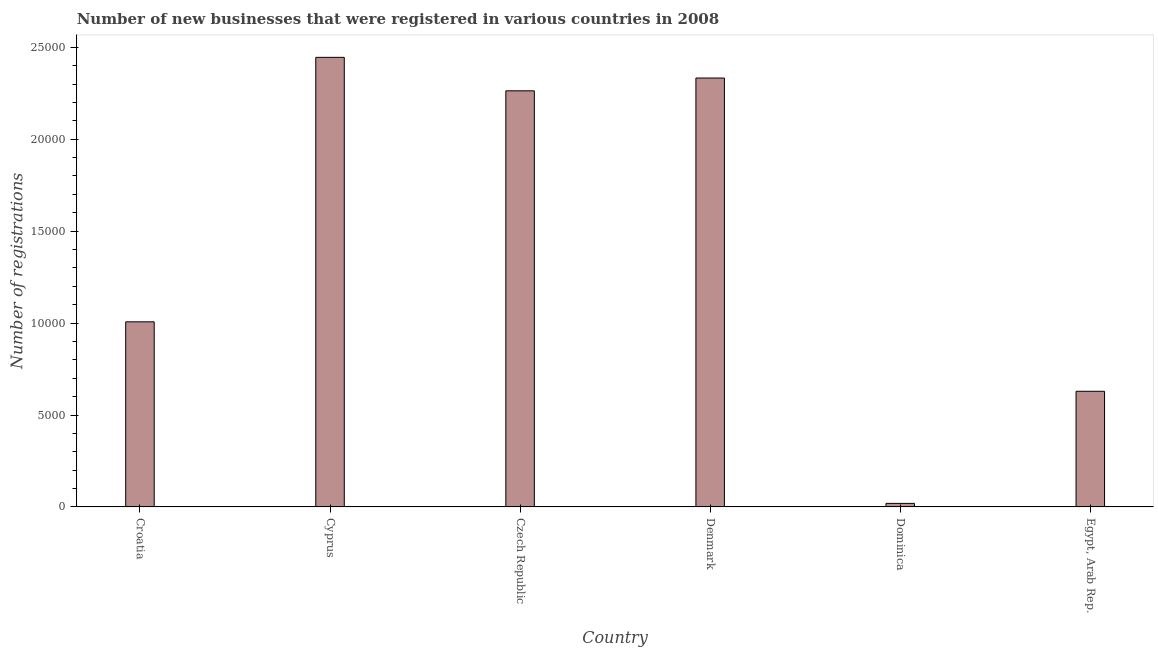Does the graph contain any zero values?
Your response must be concise. No. What is the title of the graph?
Make the answer very short. Number of new businesses that were registered in various countries in 2008. What is the label or title of the Y-axis?
Offer a terse response. Number of registrations. What is the number of new business registrations in Denmark?
Provide a short and direct response. 2.33e+04. Across all countries, what is the maximum number of new business registrations?
Your answer should be compact. 2.45e+04. Across all countries, what is the minimum number of new business registrations?
Offer a very short reply. 193. In which country was the number of new business registrations maximum?
Provide a succinct answer. Cyprus. In which country was the number of new business registrations minimum?
Give a very brief answer. Dominica. What is the sum of the number of new business registrations?
Keep it short and to the point. 8.70e+04. What is the difference between the number of new business registrations in Cyprus and Egypt, Arab Rep.?
Your answer should be compact. 1.82e+04. What is the average number of new business registrations per country?
Ensure brevity in your answer.  1.45e+04. What is the median number of new business registrations?
Provide a short and direct response. 1.64e+04. What is the ratio of the number of new business registrations in Cyprus to that in Egypt, Arab Rep.?
Provide a succinct answer. 3.89. What is the difference between the highest and the second highest number of new business registrations?
Keep it short and to the point. 1124. Is the sum of the number of new business registrations in Croatia and Denmark greater than the maximum number of new business registrations across all countries?
Keep it short and to the point. Yes. What is the difference between the highest and the lowest number of new business registrations?
Provide a succinct answer. 2.43e+04. How many bars are there?
Make the answer very short. 6. Are all the bars in the graph horizontal?
Your answer should be compact. No. What is the difference between two consecutive major ticks on the Y-axis?
Offer a terse response. 5000. Are the values on the major ticks of Y-axis written in scientific E-notation?
Provide a short and direct response. No. What is the Number of registrations of Croatia?
Your response must be concise. 1.01e+04. What is the Number of registrations in Cyprus?
Provide a short and direct response. 2.45e+04. What is the Number of registrations in Czech Republic?
Provide a short and direct response. 2.26e+04. What is the Number of registrations of Denmark?
Offer a very short reply. 2.33e+04. What is the Number of registrations in Dominica?
Your answer should be compact. 193. What is the Number of registrations in Egypt, Arab Rep.?
Your answer should be compact. 6291. What is the difference between the Number of registrations in Croatia and Cyprus?
Offer a terse response. -1.44e+04. What is the difference between the Number of registrations in Croatia and Czech Republic?
Provide a succinct answer. -1.26e+04. What is the difference between the Number of registrations in Croatia and Denmark?
Offer a terse response. -1.33e+04. What is the difference between the Number of registrations in Croatia and Dominica?
Make the answer very short. 9875. What is the difference between the Number of registrations in Croatia and Egypt, Arab Rep.?
Offer a very short reply. 3777. What is the difference between the Number of registrations in Cyprus and Czech Republic?
Your answer should be compact. 1820. What is the difference between the Number of registrations in Cyprus and Denmark?
Give a very brief answer. 1124. What is the difference between the Number of registrations in Cyprus and Dominica?
Your answer should be very brief. 2.43e+04. What is the difference between the Number of registrations in Cyprus and Egypt, Arab Rep.?
Your answer should be very brief. 1.82e+04. What is the difference between the Number of registrations in Czech Republic and Denmark?
Ensure brevity in your answer.  -696. What is the difference between the Number of registrations in Czech Republic and Dominica?
Your answer should be very brief. 2.24e+04. What is the difference between the Number of registrations in Czech Republic and Egypt, Arab Rep.?
Make the answer very short. 1.63e+04. What is the difference between the Number of registrations in Denmark and Dominica?
Offer a terse response. 2.31e+04. What is the difference between the Number of registrations in Denmark and Egypt, Arab Rep.?
Your answer should be very brief. 1.70e+04. What is the difference between the Number of registrations in Dominica and Egypt, Arab Rep.?
Give a very brief answer. -6098. What is the ratio of the Number of registrations in Croatia to that in Cyprus?
Offer a very short reply. 0.41. What is the ratio of the Number of registrations in Croatia to that in Czech Republic?
Keep it short and to the point. 0.45. What is the ratio of the Number of registrations in Croatia to that in Denmark?
Your response must be concise. 0.43. What is the ratio of the Number of registrations in Croatia to that in Dominica?
Your response must be concise. 52.17. What is the ratio of the Number of registrations in Cyprus to that in Czech Republic?
Keep it short and to the point. 1.08. What is the ratio of the Number of registrations in Cyprus to that in Denmark?
Your answer should be compact. 1.05. What is the ratio of the Number of registrations in Cyprus to that in Dominica?
Give a very brief answer. 126.7. What is the ratio of the Number of registrations in Cyprus to that in Egypt, Arab Rep.?
Provide a succinct answer. 3.89. What is the ratio of the Number of registrations in Czech Republic to that in Dominica?
Provide a short and direct response. 117.27. What is the ratio of the Number of registrations in Czech Republic to that in Egypt, Arab Rep.?
Ensure brevity in your answer.  3.6. What is the ratio of the Number of registrations in Denmark to that in Dominica?
Offer a terse response. 120.88. What is the ratio of the Number of registrations in Denmark to that in Egypt, Arab Rep.?
Make the answer very short. 3.71. What is the ratio of the Number of registrations in Dominica to that in Egypt, Arab Rep.?
Provide a succinct answer. 0.03. 